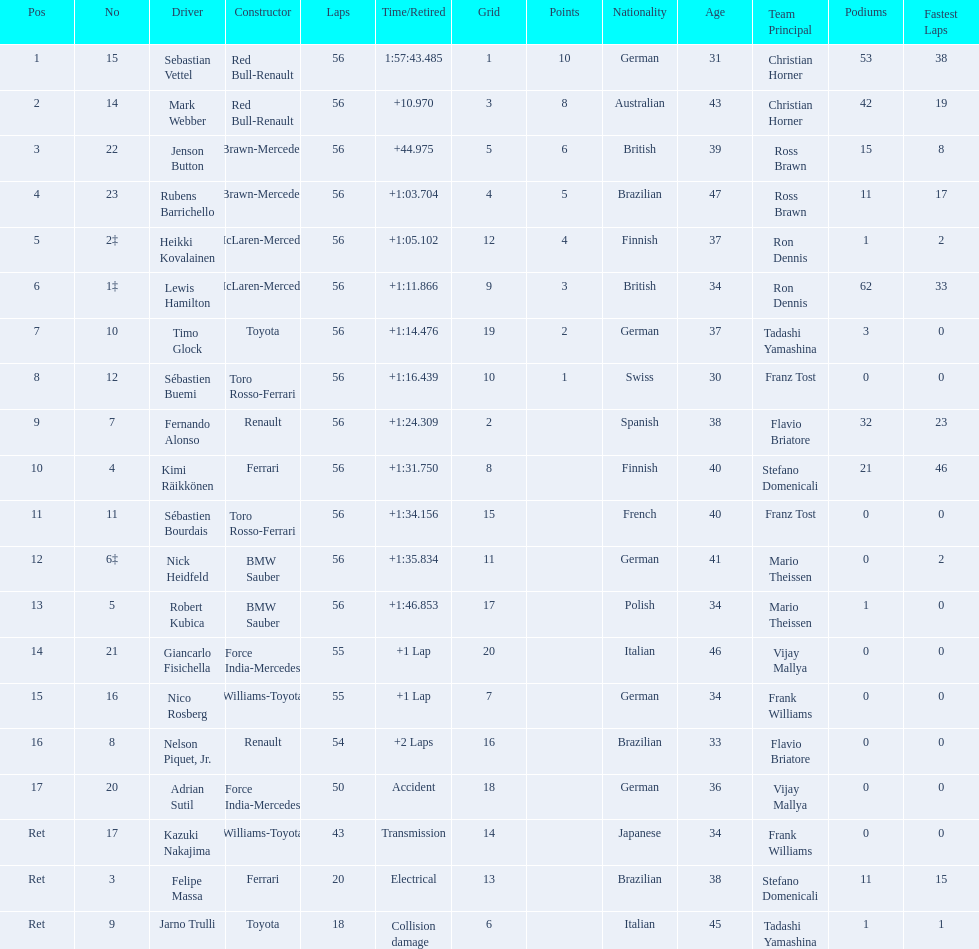Which drivers took part in the 2009 chinese grand prix? Sebastian Vettel, Mark Webber, Jenson Button, Rubens Barrichello, Heikki Kovalainen, Lewis Hamilton, Timo Glock, Sébastien Buemi, Fernando Alonso, Kimi Räikkönen, Sébastien Bourdais, Nick Heidfeld, Robert Kubica, Giancarlo Fisichella, Nico Rosberg, Nelson Piquet, Jr., Adrian Sutil, Kazuki Nakajima, Felipe Massa, Jarno Trulli. Of these, who completed all 56 laps? Sebastian Vettel, Mark Webber, Jenson Button, Rubens Barrichello, Heikki Kovalainen, Lewis Hamilton, Timo Glock, Sébastien Buemi, Fernando Alonso, Kimi Räikkönen, Sébastien Bourdais, Nick Heidfeld, Robert Kubica. Of these, which did ferrari not participate as a constructor? Sebastian Vettel, Mark Webber, Jenson Button, Rubens Barrichello, Heikki Kovalainen, Lewis Hamilton, Timo Glock, Fernando Alonso, Kimi Räikkönen, Nick Heidfeld, Robert Kubica. Of the remaining, which is in pos 1? Sebastian Vettel. 